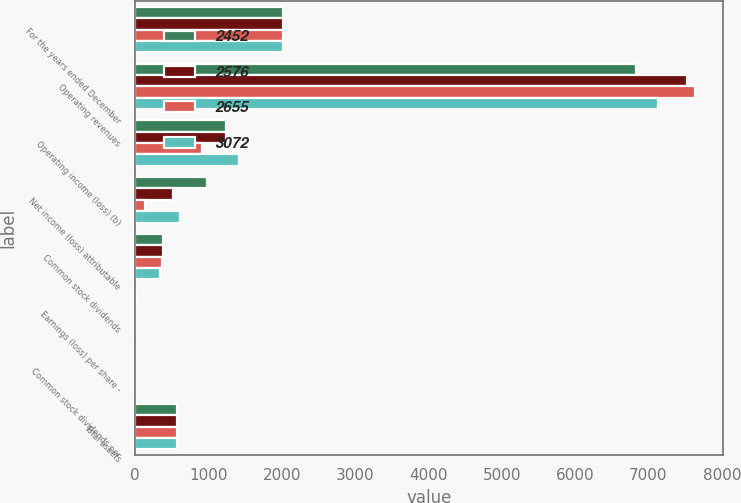Convert chart to OTSL. <chart><loc_0><loc_0><loc_500><loc_500><stacked_bar_chart><ecel><fcel>For the years ended December<fcel>Operating revenues<fcel>Operating income (loss) (b)<fcel>Net income (loss) attributable<fcel>Common stock dividends<fcel>Earnings (loss) per share -<fcel>Common stock dividends per<fcel>Total assets<nl><fcel>2452<fcel>2012<fcel>6828<fcel>1240<fcel>974<fcel>382<fcel>4.01<fcel>1.6<fcel>565.5<nl><fcel>2576<fcel>2011<fcel>7531<fcel>1241<fcel>519<fcel>375<fcel>2.15<fcel>1.55<fcel>565.5<nl><fcel>2655<fcel>2010<fcel>7638<fcel>916<fcel>139<fcel>368<fcel>0.58<fcel>1.54<fcel>565.5<nl><fcel>3072<fcel>2009<fcel>7135<fcel>1416<fcel>612<fcel>338<fcel>2.78<fcel>1.54<fcel>565.5<nl></chart> 